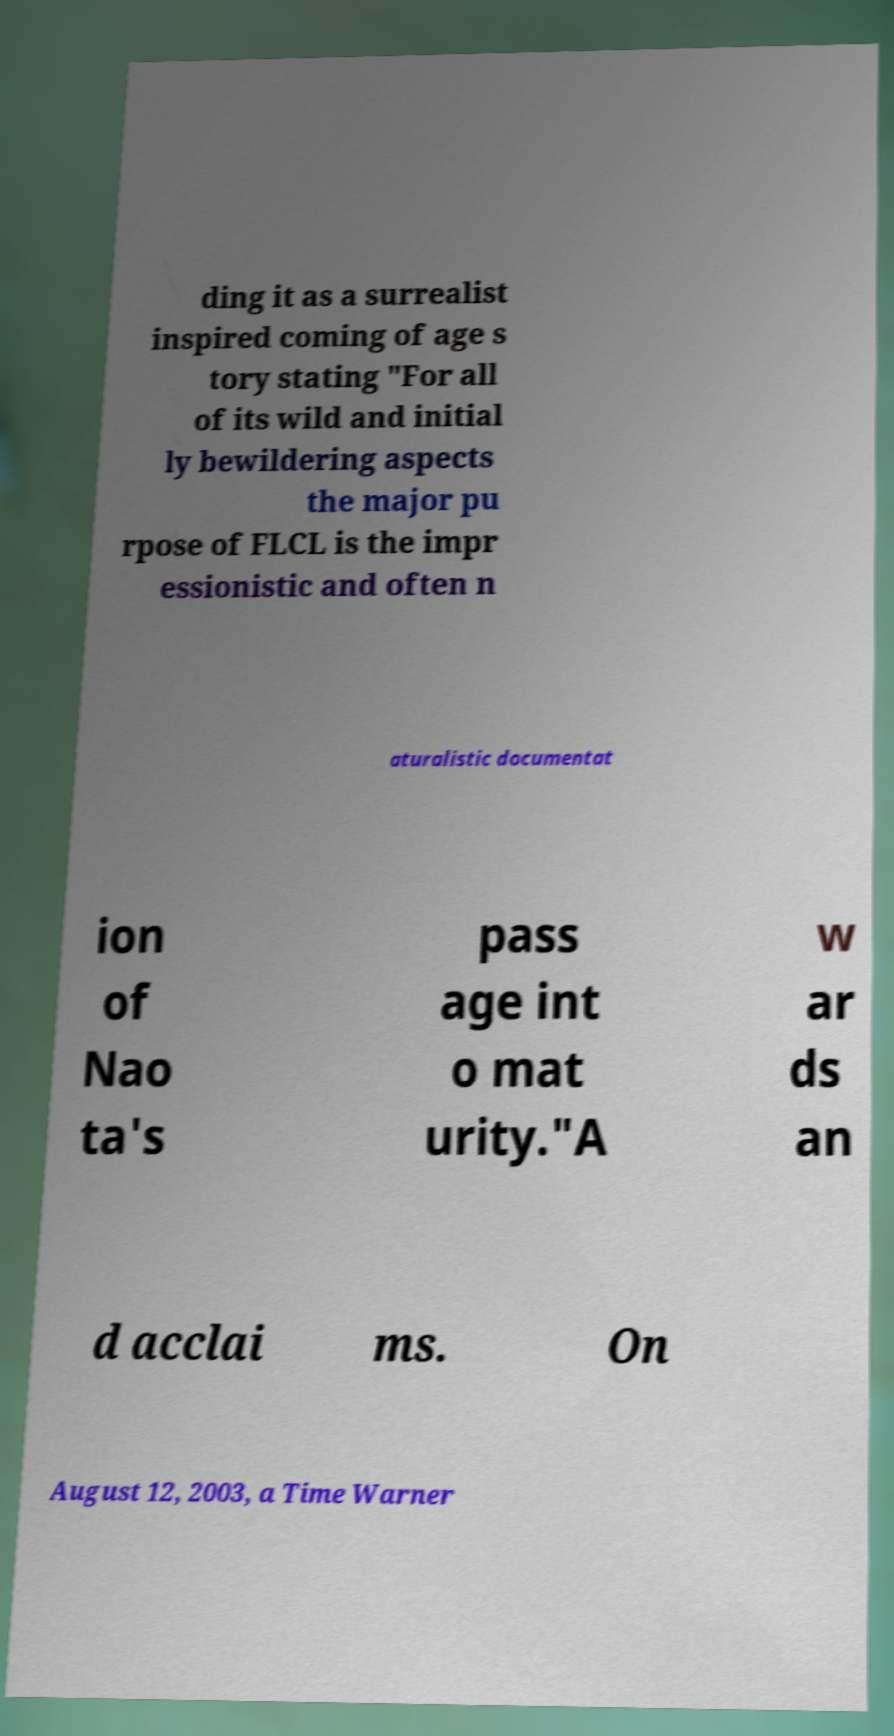For documentation purposes, I need the text within this image transcribed. Could you provide that? ding it as a surrealist inspired coming of age s tory stating "For all of its wild and initial ly bewildering aspects the major pu rpose of FLCL is the impr essionistic and often n aturalistic documentat ion of Nao ta's pass age int o mat urity."A w ar ds an d acclai ms. On August 12, 2003, a Time Warner 